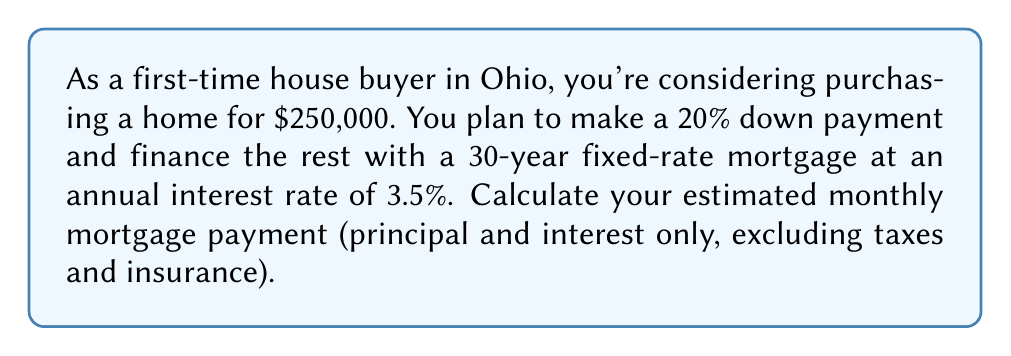Give your solution to this math problem. To calculate the monthly mortgage payment, we'll use the standard mortgage payment formula:

$$ P = L \frac{r(1+r)^n}{(1+r)^n - 1} $$

Where:
$P$ = monthly payment
$L$ = loan amount
$r$ = monthly interest rate
$n$ = total number of months

Step 1: Calculate the loan amount
Down payment = $250,000 \times 20\% = $50,000
Loan amount (L) = $250,000 - $50,000 = $200,000

Step 2: Convert annual interest rate to monthly
Monthly interest rate (r) = $\frac{3.5\%}{12} = 0.002916667$

Step 3: Calculate total number of months
For a 30-year mortgage, n = $30 \times 12 = 360$ months

Step 4: Apply the formula
$$ P = 200,000 \times \frac{0.002916667(1+0.002916667)^{360}}{(1+0.002916667)^{360} - 1} $$

Step 5: Solve the equation
$$ P = 200,000 \times 0.004490175 = 898.04 $$

Therefore, the estimated monthly mortgage payment is $898.04.
Answer: $898.04 per month 